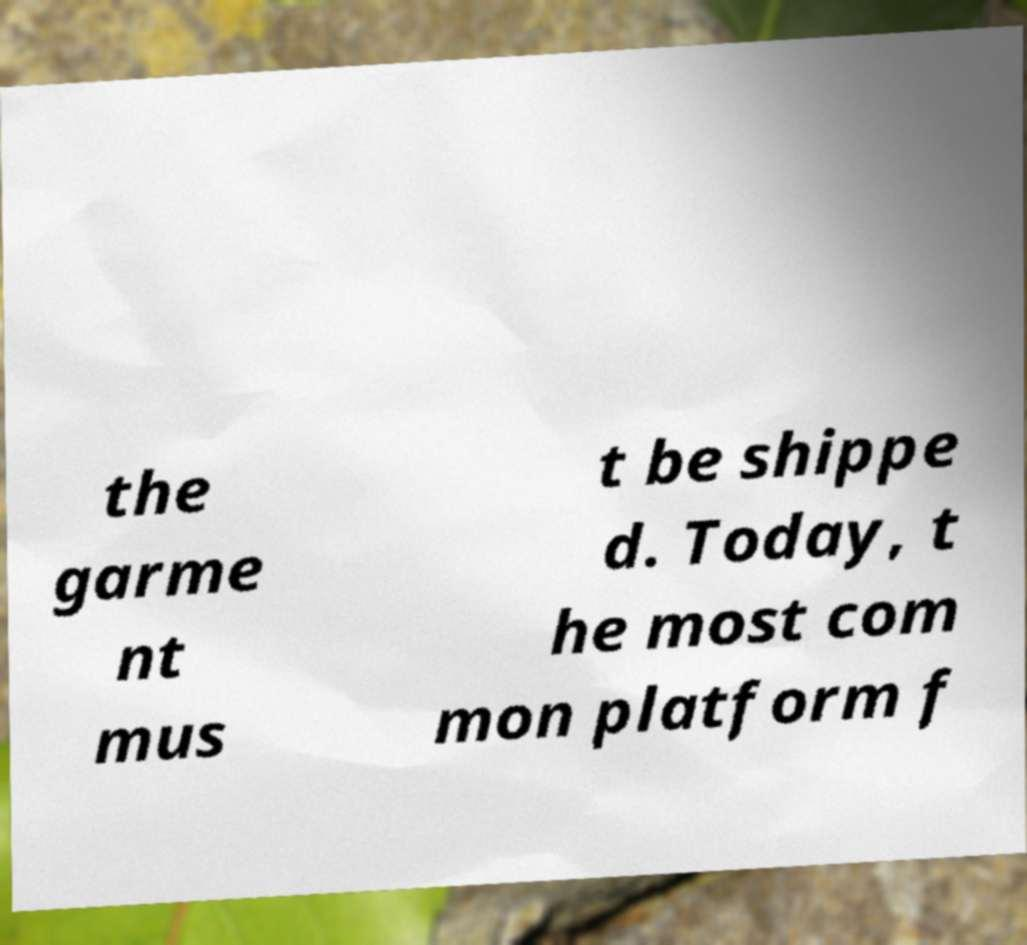Can you read and provide the text displayed in the image?This photo seems to have some interesting text. Can you extract and type it out for me? the garme nt mus t be shippe d. Today, t he most com mon platform f 